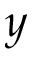<formula> <loc_0><loc_0><loc_500><loc_500>y</formula> 